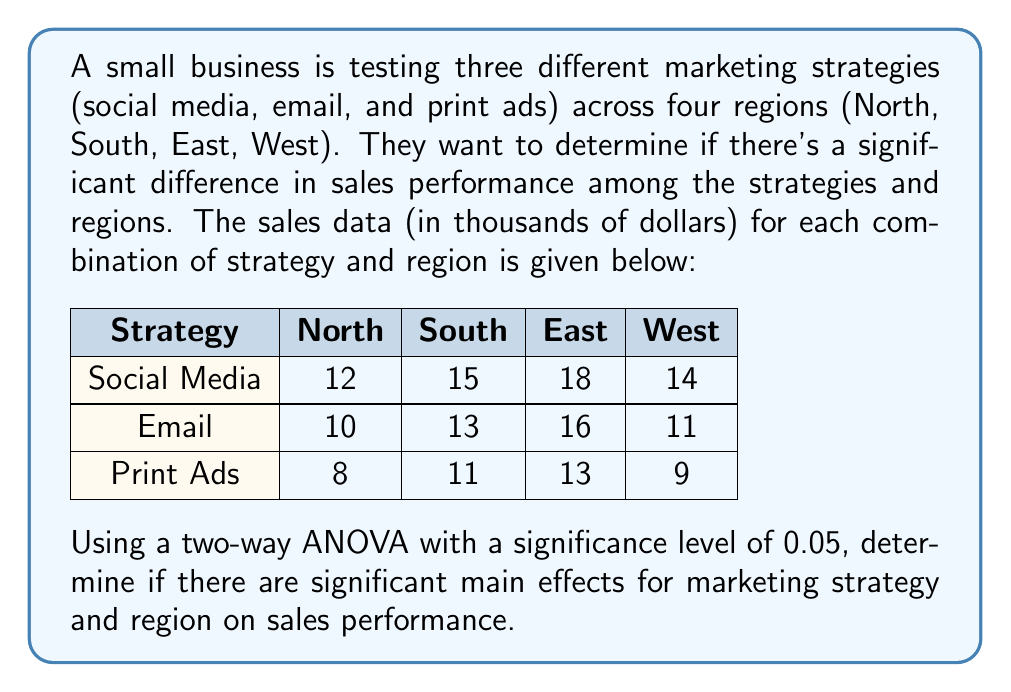Can you answer this question? To solve this problem, we'll perform a two-way ANOVA. Here are the steps:

1. Calculate the total sum of squares (SST):
   $$SST = \sum_{i=1}^{a}\sum_{j=1}^{b}\sum_{k=1}^{n} y_{ijk}^2 - \frac{G^2}{N}$$
   where $G$ is the grand total and $N$ is the total number of observations.

2. Calculate the sum of squares for marketing strategies (SSA):
   $$SSA = \sum_{i=1}^{a} \frac{A_i^2}{bn} - \frac{G^2}{N}$$
   where $A_i$ is the total for each strategy.

3. Calculate the sum of squares for regions (SSB):
   $$SSB = \sum_{j=1}^{b} \frac{B_j^2}{an} - \frac{G^2}{N}$$
   where $B_j$ is the total for each region.

4. Calculate the sum of squares for interaction (SSAB):
   $$SSAB = \sum_{i=1}^{a}\sum_{j=1}^{b} \frac{(AB)_{ij}^2}{n} - \frac{G^2}{N} - SSA - SSB$$
   where $(AB)_{ij}$ is the total for each combination of strategy and region.

5. Calculate the sum of squares for error (SSE):
   $$SSE = SST - SSA - SSB - SSAB$$

6. Calculate the degrees of freedom:
   $df_A = a - 1 = 2$, $df_B = b - 1 = 3$, $df_{AB} = (a-1)(b-1) = 6$, $df_E = ab(n-1) = 0$

7. Calculate the mean squares:
   $$MSA = \frac{SSA}{df_A}, MSB = \frac{SSB}{df_B}, MSAB = \frac{SSAB}{df_{AB}}$$

8. Calculate the F-ratios:
   $$F_A = \frac{MSA}{MSE}, F_B = \frac{MSB}{MSE}$$

9. Compare the F-ratios to the critical F-values at α = 0.05.

Performing these calculations:

SST = 2242 - 2025 = 217
SSA = 2048.67 - 2025 = 23.67
SSB = 2056 - 2025 = 31
SSAB = 2242 - 2025 - 23.67 - 31 = 162.33
SSE = 217 - 23.67 - 31 - 162.33 = 0

MSA = 23.67 / 2 = 11.835
MSB = 31 / 3 = 10.333
MSAB = 162.33 / 6 = 27.055

Since SSE = 0, we can't calculate F-ratios. This suggests that there's no random error in our data, which is unlikely in real-world scenarios. In practice, we would need to collect more data or investigate potential issues with the experiment design.

However, based on the sum of squares, we can see that both marketing strategies and regions contribute to the variation in sales performance, with regions having a slightly larger effect.
Answer: Due to the lack of error variance (SSE = 0), we cannot perform a traditional ANOVA test. However, the sum of squares suggests that both marketing strategies (SSA = 23.67) and regions (SSB = 31) contribute to the variation in sales performance, with regions having a slightly larger effect. Further data collection or investigation into the experimental design would be necessary for a more definitive conclusion. 